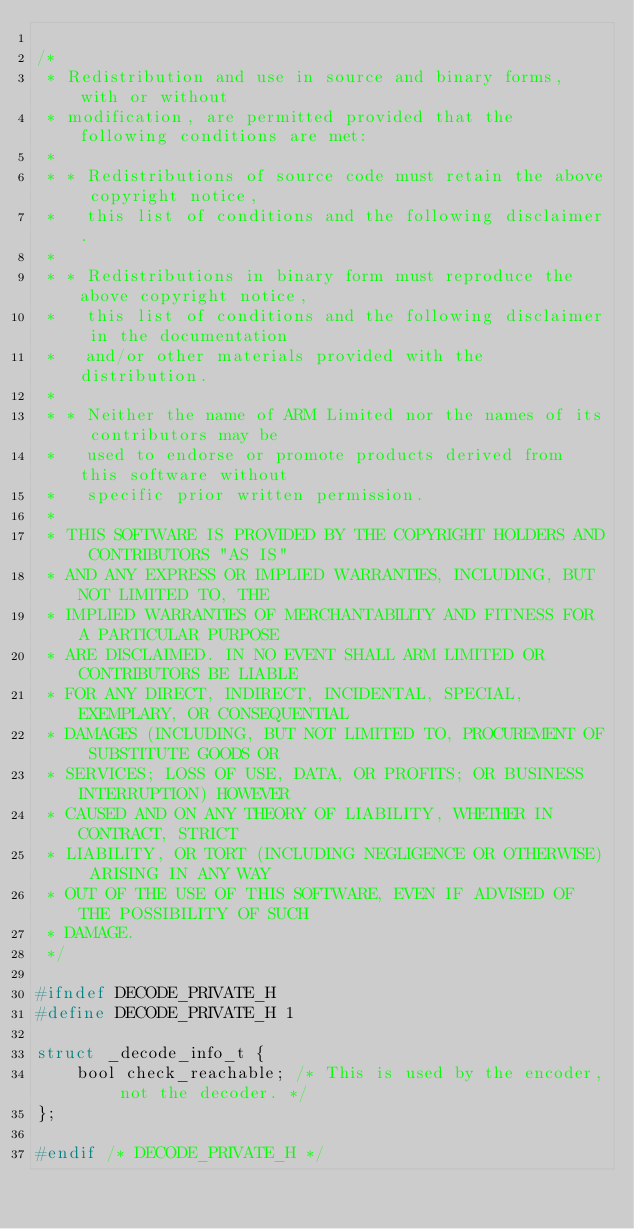<code> <loc_0><loc_0><loc_500><loc_500><_C_>
/*
 * Redistribution and use in source and binary forms, with or without
 * modification, are permitted provided that the following conditions are met:
 *
 * * Redistributions of source code must retain the above copyright notice,
 *   this list of conditions and the following disclaimer.
 *
 * * Redistributions in binary form must reproduce the above copyright notice,
 *   this list of conditions and the following disclaimer in the documentation
 *   and/or other materials provided with the distribution.
 *
 * * Neither the name of ARM Limited nor the names of its contributors may be
 *   used to endorse or promote products derived from this software without
 *   specific prior written permission.
 *
 * THIS SOFTWARE IS PROVIDED BY THE COPYRIGHT HOLDERS AND CONTRIBUTORS "AS IS"
 * AND ANY EXPRESS OR IMPLIED WARRANTIES, INCLUDING, BUT NOT LIMITED TO, THE
 * IMPLIED WARRANTIES OF MERCHANTABILITY AND FITNESS FOR A PARTICULAR PURPOSE
 * ARE DISCLAIMED. IN NO EVENT SHALL ARM LIMITED OR CONTRIBUTORS BE LIABLE
 * FOR ANY DIRECT, INDIRECT, INCIDENTAL, SPECIAL, EXEMPLARY, OR CONSEQUENTIAL
 * DAMAGES (INCLUDING, BUT NOT LIMITED TO, PROCUREMENT OF SUBSTITUTE GOODS OR
 * SERVICES; LOSS OF USE, DATA, OR PROFITS; OR BUSINESS INTERRUPTION) HOWEVER
 * CAUSED AND ON ANY THEORY OF LIABILITY, WHETHER IN CONTRACT, STRICT
 * LIABILITY, OR TORT (INCLUDING NEGLIGENCE OR OTHERWISE) ARISING IN ANY WAY
 * OUT OF THE USE OF THIS SOFTWARE, EVEN IF ADVISED OF THE POSSIBILITY OF SUCH
 * DAMAGE.
 */

#ifndef DECODE_PRIVATE_H
#define DECODE_PRIVATE_H 1

struct _decode_info_t {
    bool check_reachable; /* This is used by the encoder, not the decoder. */
};

#endif /* DECODE_PRIVATE_H */
</code> 